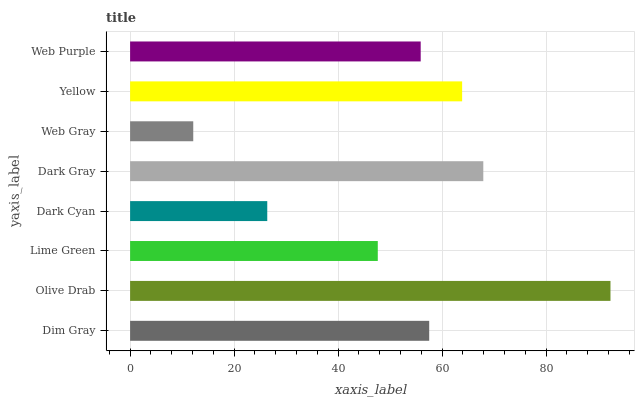Is Web Gray the minimum?
Answer yes or no. Yes. Is Olive Drab the maximum?
Answer yes or no. Yes. Is Lime Green the minimum?
Answer yes or no. No. Is Lime Green the maximum?
Answer yes or no. No. Is Olive Drab greater than Lime Green?
Answer yes or no. Yes. Is Lime Green less than Olive Drab?
Answer yes or no. Yes. Is Lime Green greater than Olive Drab?
Answer yes or no. No. Is Olive Drab less than Lime Green?
Answer yes or no. No. Is Dim Gray the high median?
Answer yes or no. Yes. Is Web Purple the low median?
Answer yes or no. Yes. Is Web Purple the high median?
Answer yes or no. No. Is Lime Green the low median?
Answer yes or no. No. 